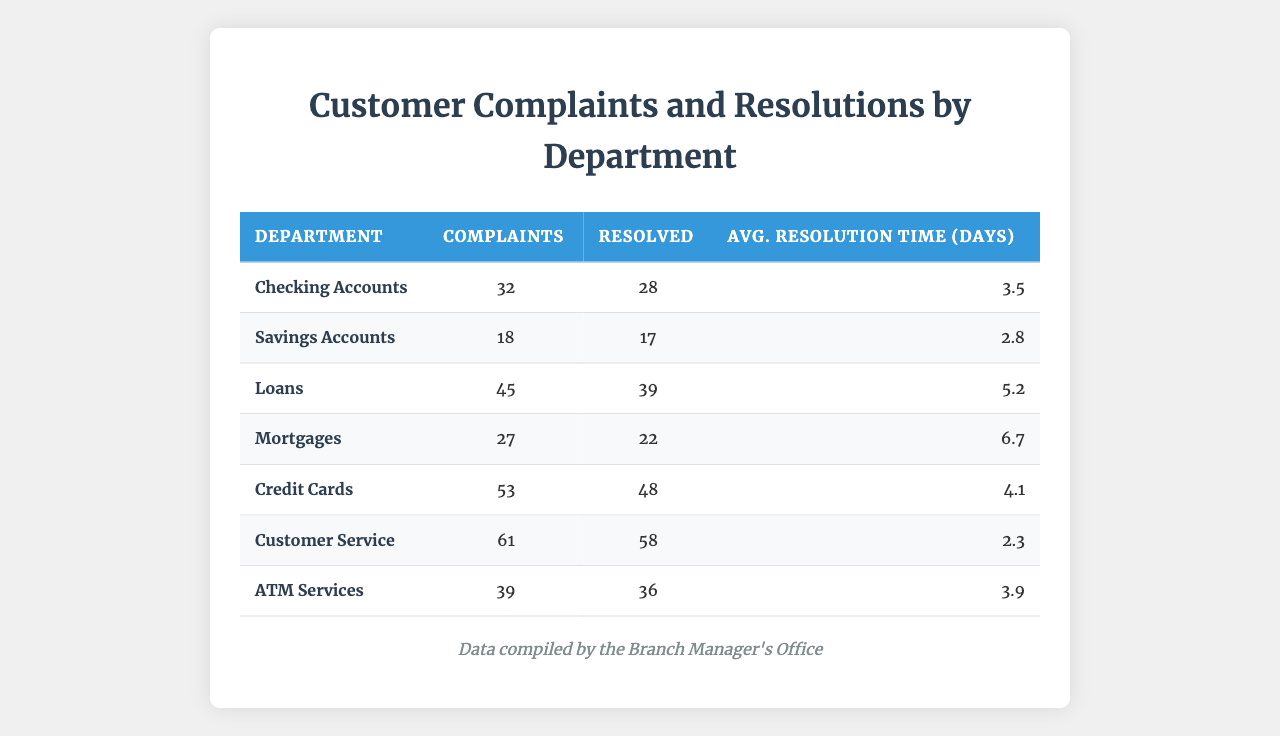What department has the highest number of complaints? By reviewing the data, the "Customer Service" department has 61 complaints, which is the highest among all departments listed.
Answer: Customer Service What is the average resolution time for Loan complaints? The average resolution time for Loans, as listed in the table, is 5.2 days.
Answer: 5.2 days How many complaints are resolved in the Savings Accounts department? The table indicates that 17 complaints were resolved in the Savings Accounts department.
Answer: 17 What is the total number of complaints across all departments? Adding up the complaints from all departments: (32 + 18 + 45 + 27 + 53 + 61 + 39) gives us 275 total complaints.
Answer: 275 Which department has the lowest average resolution time? The "Customer Service" department has the lowest average resolution time at 2.3 days.
Answer: Customer Service Is the number of unresolved complaints in the Mortgages department higher than those resolved? The Mortgages department has 27 complaints and 22 resolved. Thus, the unresolved complaints (27 - 22 = 5) are indeed higher than those resolved.
Answer: Yes Which department had more complaints: ATMs or Mortgages? Comparing the two, ATM Services has 39 complaints while Mortgages has 27 complaints. Therefore, ATMs had more complaints.
Answer: ATM Services What is the total number of complaints resolved in the Credit Cards and Loans departments combined? By adding the resolved complaints: (48 from Credit Cards + 39 from Loans), we find there are 87 complaints resolved combined.
Answer: 87 What is the difference in resolution time between Mortgages and Checking Accounts? The average resolution time for Mortgages is 6.7 days and for Checking Accounts is 3.5 days. The difference is 6.7 - 3.5 = 3.2 days.
Answer: 3.2 days Is the percentage of resolved complaints in the Loans department above or below 80%? For Loans, 39 out of 45 complaints are resolved, which is approximately 86.67% (39/45 * 100). Thus, it is above 80%.
Answer: Above 80% 